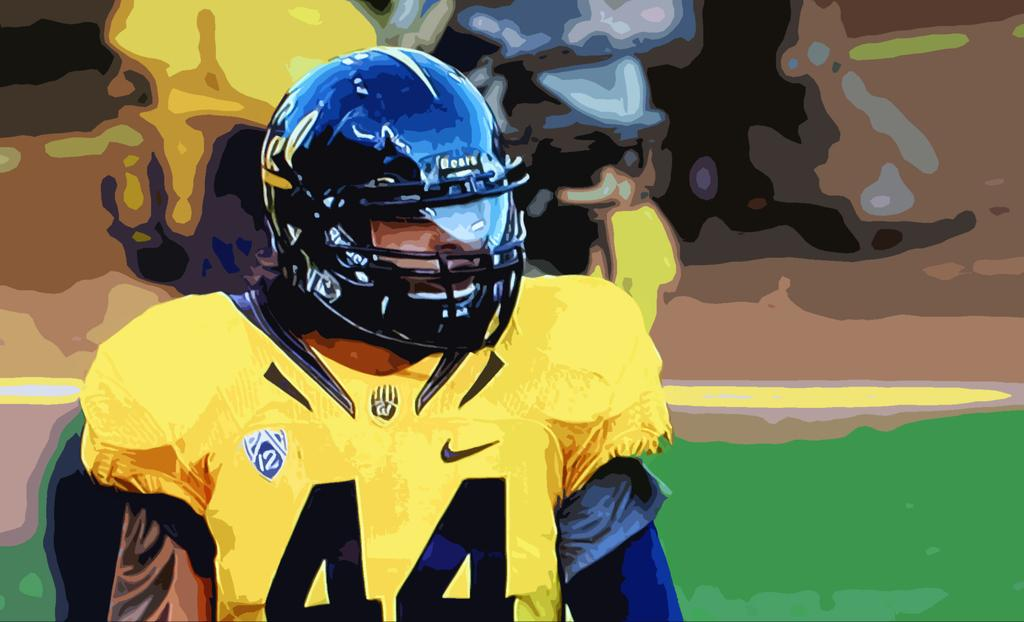What is the main subject of the image? There is a painting in the image. What is depicted in the painting? The painting depicts a person. What is the person wearing in the painting? The person is wearing a uniform and a helmet. What type of juice is being measured with a fork in the image? There is no juice or fork present in the image; it features a painting of a person wearing a uniform and a helmet. 